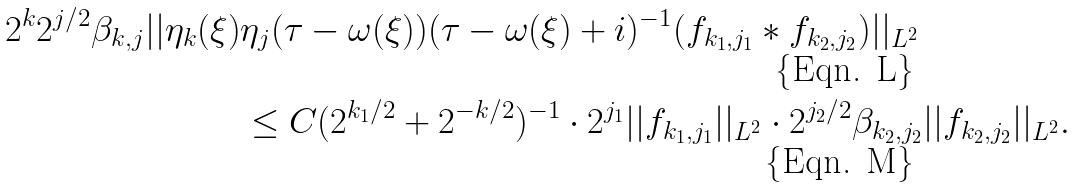Convert formula to latex. <formula><loc_0><loc_0><loc_500><loc_500>2 ^ { k } 2 ^ { j / 2 } \beta _ { k , j } | | \eta _ { k } ( \xi ) & \eta _ { j } ( \tau - \omega ( \xi ) ) ( \tau - \omega ( \xi ) + i ) ^ { - 1 } ( f _ { k _ { 1 } , j _ { 1 } } \ast f _ { k _ { 2 } , j _ { 2 } } ) | | _ { L ^ { 2 } } \\ & \leq C ( 2 ^ { k _ { 1 } / 2 } + 2 ^ { - k / 2 } ) ^ { - 1 } \cdot 2 ^ { j _ { 1 } } | | f _ { k _ { 1 } , j _ { 1 } } | | _ { L ^ { 2 } } \cdot 2 ^ { j _ { 2 } / 2 } \beta _ { k _ { 2 } , j _ { 2 } } | | f _ { k _ { 2 } , j _ { 2 } } | | _ { L ^ { 2 } } .</formula> 